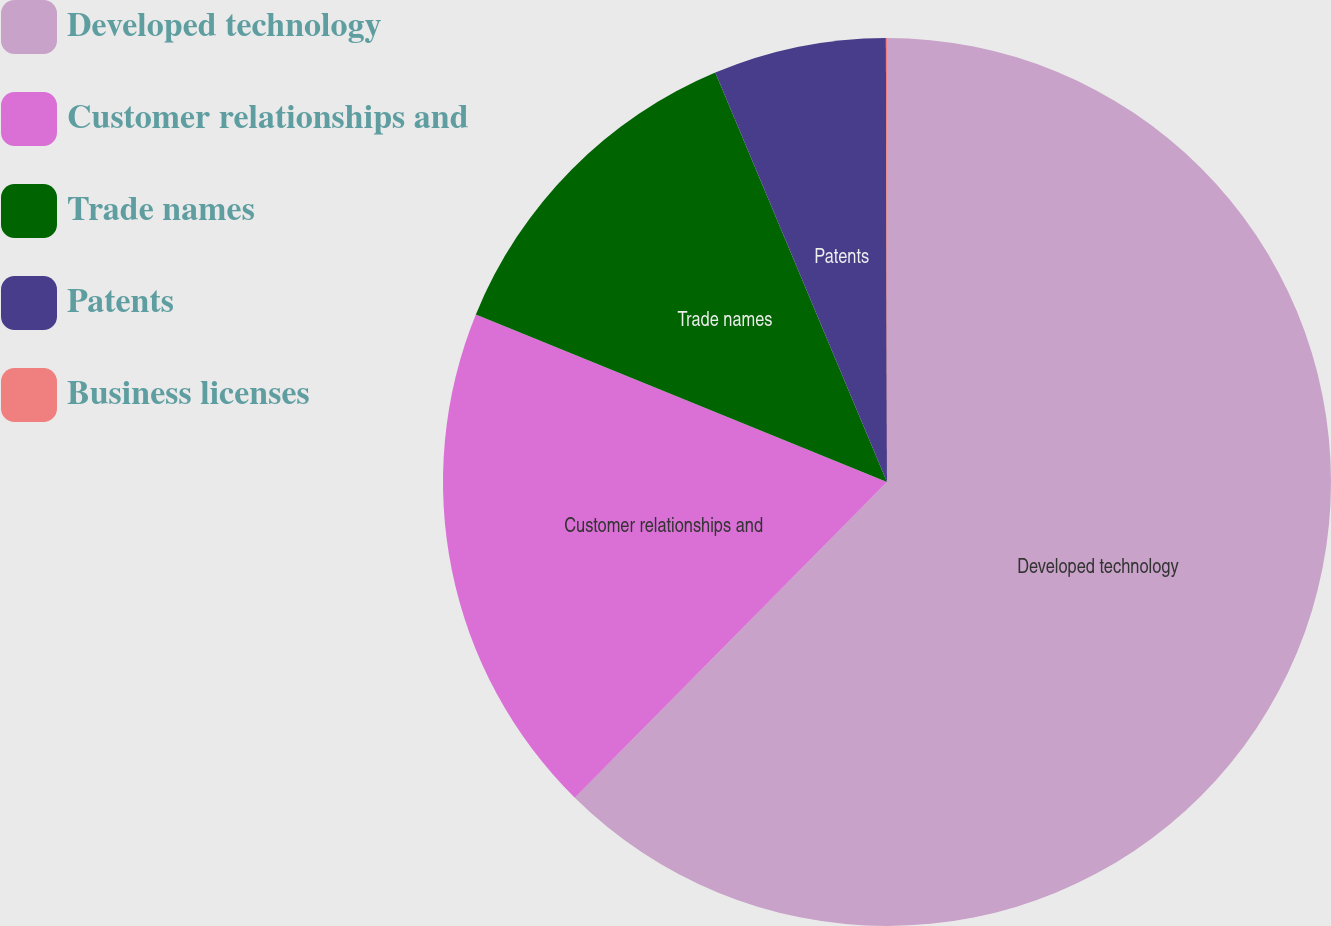Convert chart to OTSL. <chart><loc_0><loc_0><loc_500><loc_500><pie_chart><fcel>Developed technology<fcel>Customer relationships and<fcel>Trade names<fcel>Patents<fcel>Business licenses<nl><fcel>62.41%<fcel>18.75%<fcel>12.52%<fcel>6.28%<fcel>0.04%<nl></chart> 